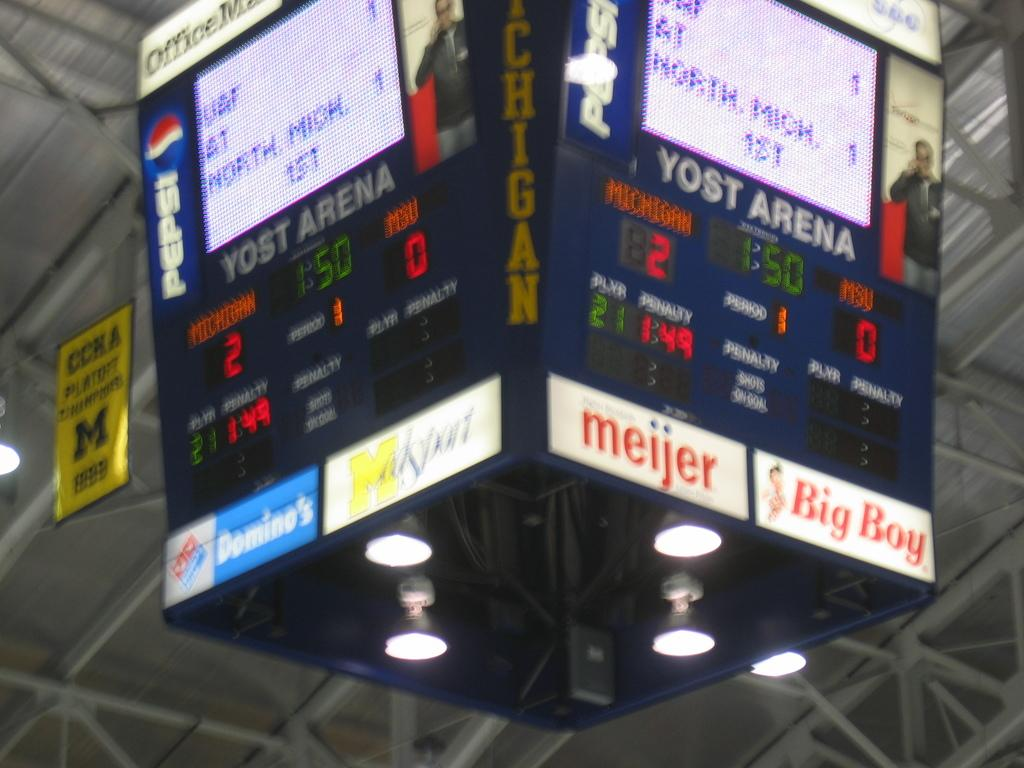<image>
Present a compact description of the photo's key features. The central roof mounted four sided scoreboard at Yost Arena. 